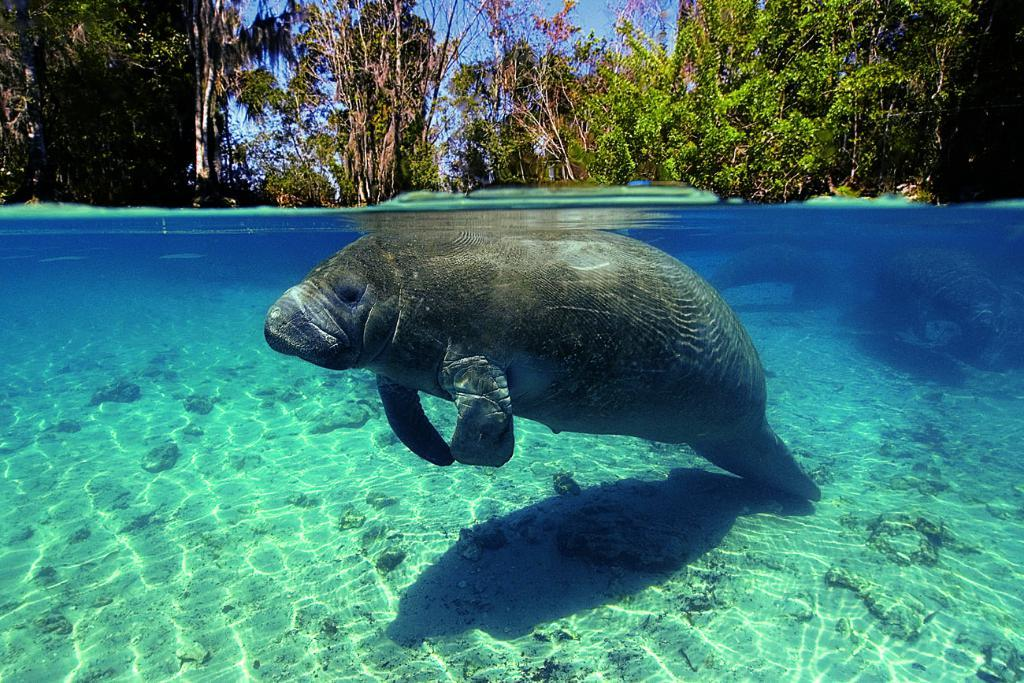What is in the water in the image? There is a fish in the water in the image. What can be seen in the background of the image? There are trees and the sky visible in the background of the image. Can you determine the time of day the image was taken? The image was likely taken during a day, as the sky is visible and not dark. What type of quicksand can be seen in the image? There is no quicksand present in the image; it features a fish in the water and trees in the background. How is the coal distributed in the image? There is no coal present in the image, so it cannot be distributed or discussed. 